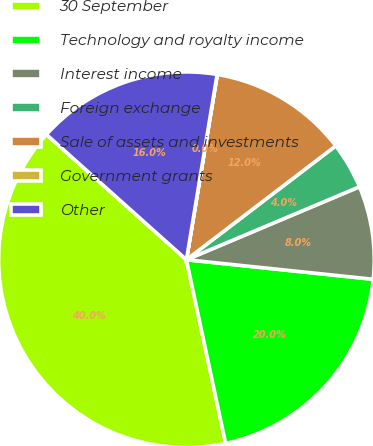Convert chart to OTSL. <chart><loc_0><loc_0><loc_500><loc_500><pie_chart><fcel>30 September<fcel>Technology and royalty income<fcel>Interest income<fcel>Foreign exchange<fcel>Sale of assets and investments<fcel>Government grants<fcel>Other<nl><fcel>39.96%<fcel>19.99%<fcel>8.01%<fcel>4.02%<fcel>12.0%<fcel>0.02%<fcel>16.0%<nl></chart> 